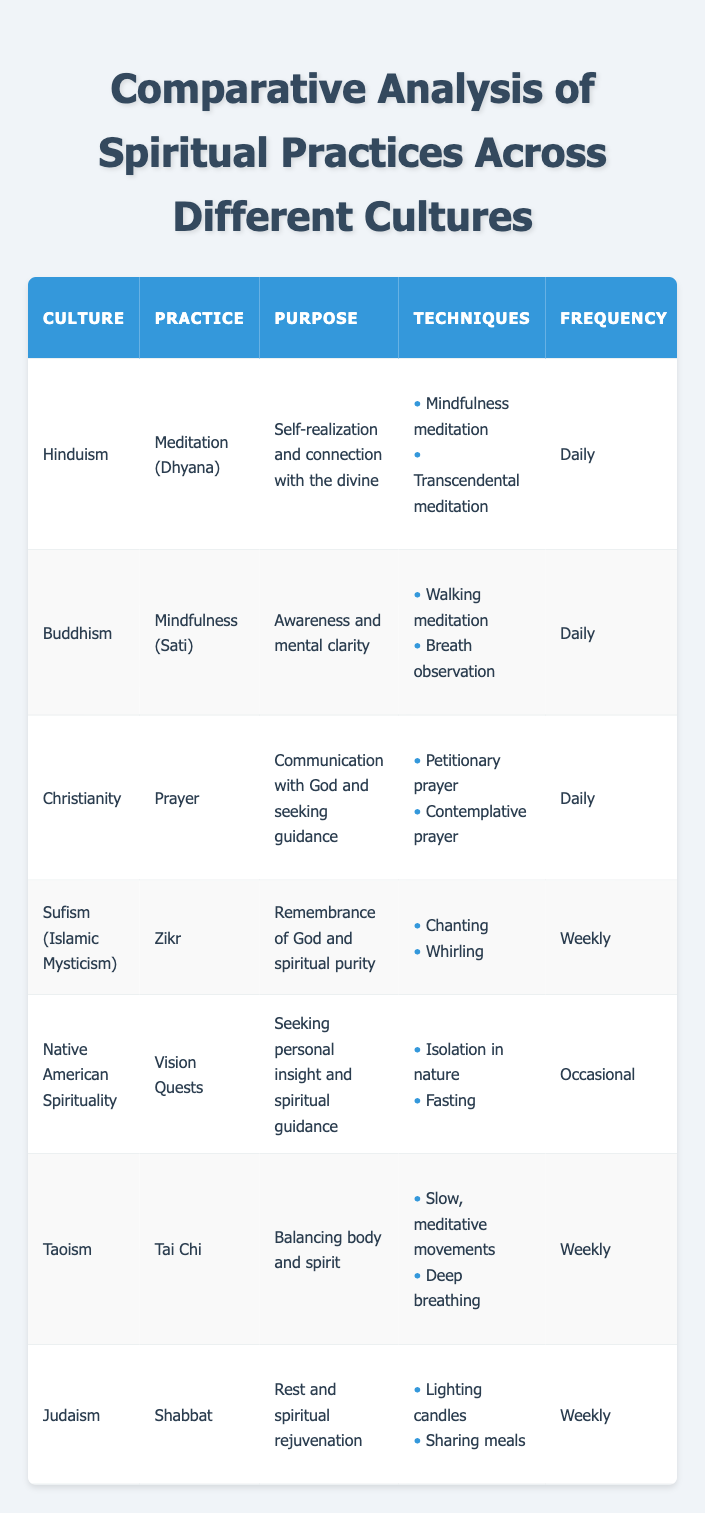What is the practice associated with Buddhism? According to the table, Buddhism is associated with the practice of Mindfulness (Sati). This information can be directly retrieved from the second row of the table under the 'Practice' column for the culture 'Buddhism'.
Answer: Mindfulness (Sati) Which culture practices Tai Chi? Looking at the table, Tai Chi is practiced in Taoism. This information can be found in the row for the culture 'Taoism', where the 'Practice' column indicates Tai Chi.
Answer: Taoism Is the frequency of spiritual practices for Christianity daily? According to the table, Christianity's practice of Prayer is indeed noted as occurring daily in the 'Frequency' column. This can be checked by looking at the row corresponding to Christianity in the table.
Answer: Yes Which spiritual practices involve community gatherings? The table shows that Hinduism (Group meditation sessions), Buddhism (Sangha gatherings), Christianity (Worship services), Sufism (Sufi gatherings), and Judaism (Community observance) all include community aspects. By reviewing the community aspect column, we see each of these practices involves a form of community gathering.
Answer: Hinduism, Buddhism, Christianity, Sufism, Judaism How many practices are associated with weekly frequency? By examining the frequency column, we identify the practices with 'Weekly' frequency: Zikr from Sufism, Tai Chi from Taoism, and Shabbat from Judaism. Therefore, 3 practices are identified as having a weekly frequency.
Answer: 3 What is the purpose of Meditation (Dhyana) in Hinduism? The purpose of Meditation (Dhyana) in Hinduism, as listed in the table, is self-realization and connection with the divine. This can be found by looking at the row for Hinduism and checking the 'Purpose' associated with Meditation (Dhyana).
Answer: Self-realization and connection with the divine Are the sacred texts for Taoism and Native American Spirituality the same? Checking the 'Sacred Text' column, we can see that the sacred text for Taoism is Tao Te Ching, while for Native American Spirituality it is Oral traditions. Since these are different, the answer is no.
Answer: No Which spiritual practice has the highest frequency of execution? In the frequency data, daily practices are associated with Hinduism (Meditation), Buddhism (Mindfulness), and Christianity (Prayer). All three of these practices occur daily. To summarize, there is a tie in the frequency, with three practices executing daily.
Answer: 3 practices 